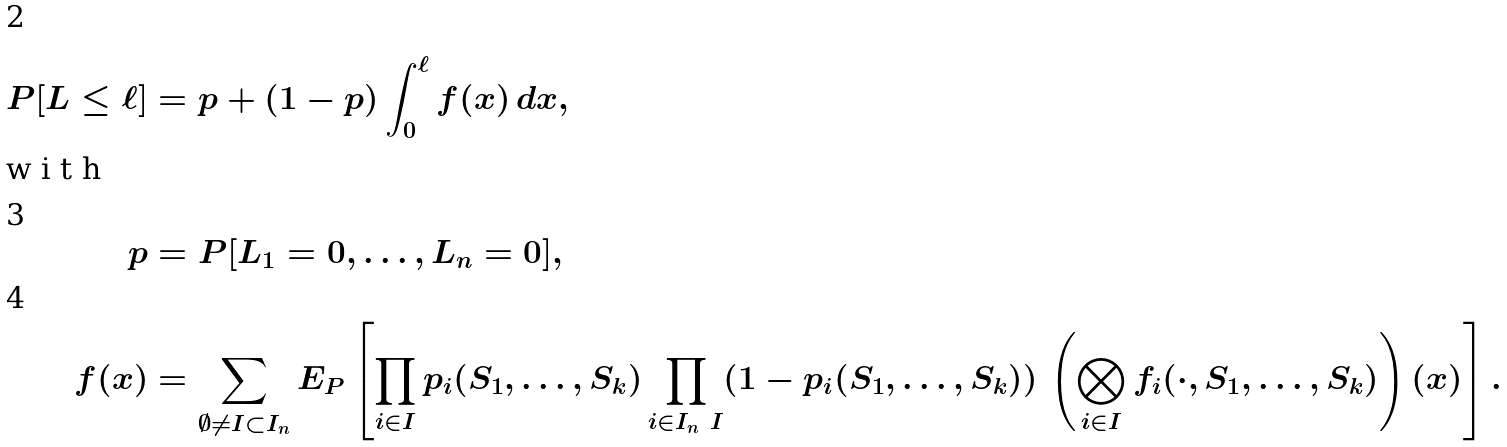Convert formula to latex. <formula><loc_0><loc_0><loc_500><loc_500>P [ L \leq \ell ] & = p + ( 1 - p ) \int _ { 0 } ^ { \ell } f ( x ) \, d x , \\ \intertext { w i t h } p & = P [ L _ { 1 } = 0 , \dots , L _ { n } = 0 ] , \\ f ( x ) & = \sum _ { \emptyset \not = I \subset I _ { n } } E _ { P } \left [ \prod _ { i \in I } p _ { i } ( S _ { 1 } , \dots , S _ { k } ) \prod _ { i \in I _ { n } \ I } ( 1 - p _ { i } ( S _ { 1 } , \dots , S _ { k } ) ) \, \left ( \bigotimes _ { i \in I } f _ { i } ( \cdot , S _ { 1 } , \dots , S _ { k } ) \right ) ( x ) \right ] .</formula> 